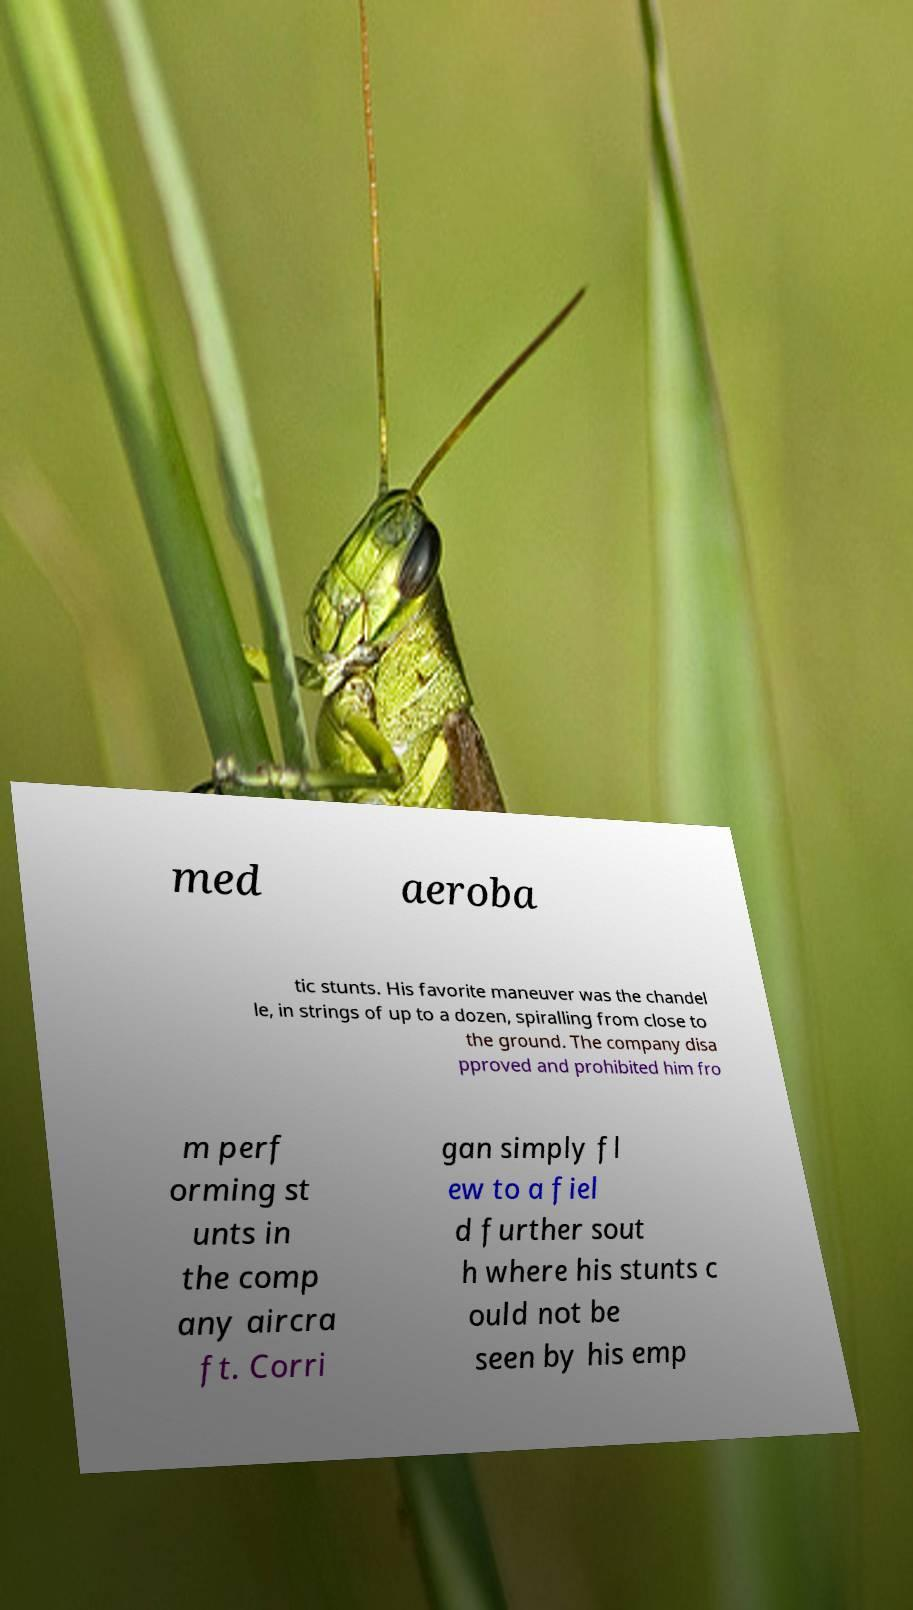Can you read and provide the text displayed in the image?This photo seems to have some interesting text. Can you extract and type it out for me? med aeroba tic stunts. His favorite maneuver was the chandel le, in strings of up to a dozen, spiralling from close to the ground. The company disa pproved and prohibited him fro m perf orming st unts in the comp any aircra ft. Corri gan simply fl ew to a fiel d further sout h where his stunts c ould not be seen by his emp 